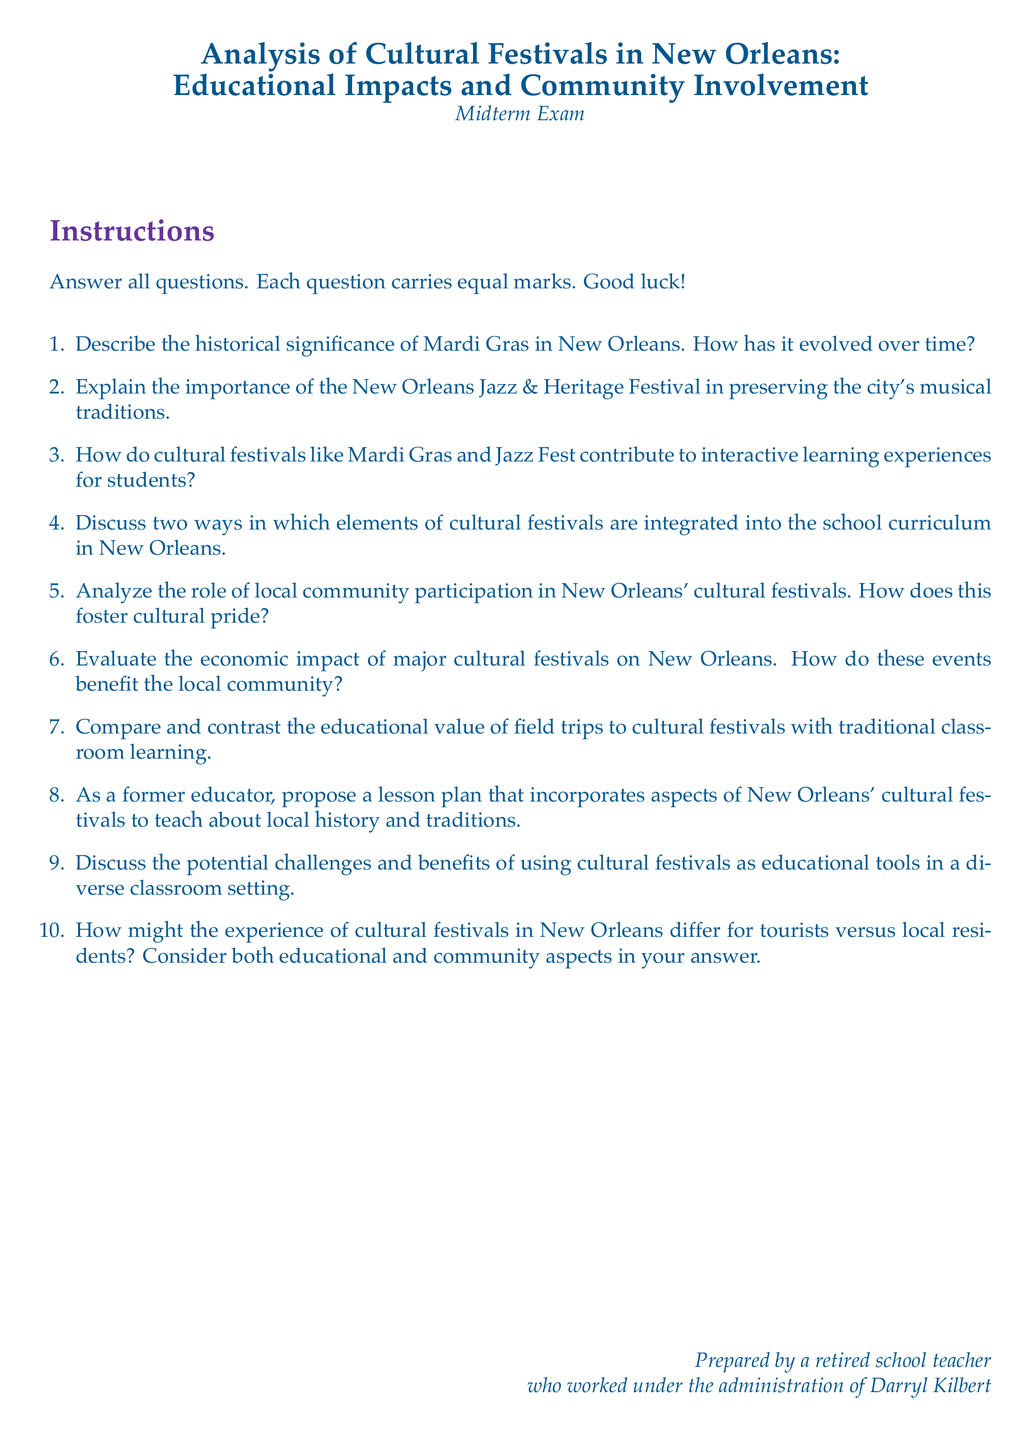What is the title of the midterm exam? The title of the midterm exam is clearly stated at the beginning of the document.
Answer: Analysis of Cultural Festivals in New Orleans: Educational Impacts and Community Involvement Who prepared the midterm exam? The document includes a note at the end identifying the author of the exam.
Answer: A retired school teacher What is the significance of Mardi Gras mentioned in the exam? The exam includes a specific question aimed at understanding this aspect.
Answer: Historical significance How many questions are in the exam? The document lists the questions in an enumerated format.
Answer: Ten What festival is known for preserving New Orleans' musical traditions? A specific question in the exam points to this festival.
Answer: New Orleans Jazz & Heritage Festival What type of learning experience do cultural festivals provide for students? The exam contains a question regarding the nature of learning experiences.
Answer: Interactive learning What is one challenge of using cultural festivals as educational tools? The exam poses a question addressing potential challenges.
Answer: Cultural diversity What is suggested as an evaluation aspect of cultural festivals? One of the questions in the exam is focused on evaluating this.
Answer: Economic impact What should be proposed in question eight of the exam? Question eight asks for a specific educational element in the context of cultural festivals.
Answer: A lesson plan What impact do cultural festivals have on local community participation? One of the questions in the exam asks for an analysis of this role.
Answer: Fosters cultural pride 